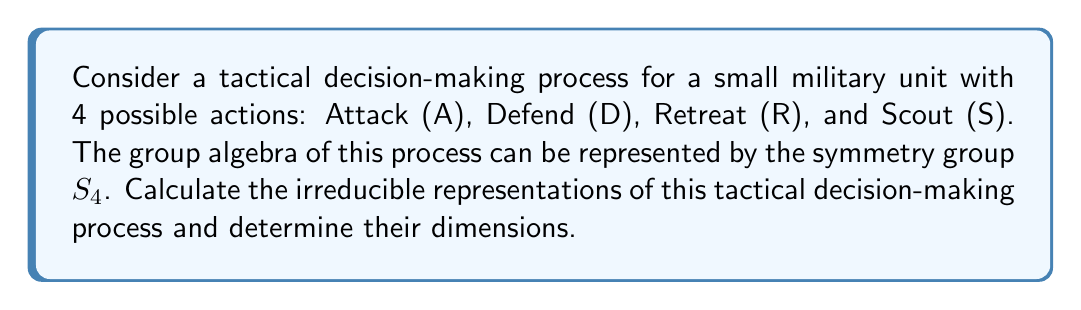Can you solve this math problem? To calculate the irreducible representations of the tactical decision-making process, we'll follow these steps:

1) First, recall that the number of irreducible representations of a group is equal to the number of conjugacy classes. For $S_4$, there are 5 conjugacy classes:
   - (1) Identity
   - (2) 2-cycles
   - (3) 3-cycles
   - (4) 4-cycles
   - (2,2) Double transpositions

2) The sum of the squares of the dimensions of the irreducible representations must equal the order of the group. For $S_4$, this means:

   $$d_1^2 + d_2^2 + d_3^2 + d_4^2 + d_5^2 = |S_4| = 24$$

3) We know that every group has a trivial representation of dimension 1, and $S_4$ has a sign representation of dimension 1.

4) $S_4$ acts on 4 points, giving a standard representation of dimension 3 (4 - 1 = 3).

5) Using the remaining two dimensions and the equation from step 2, we can deduce:

   $$1^2 + 1^2 + 3^2 + d_4^2 + d_5^2 = 24$$
   $$11 + d_4^2 + d_5^2 = 24$$
   $$d_4^2 + d_5^2 = 13$$

6) The only integer solution for this is $d_4 = 3$ and $d_5 = 2$.

Therefore, the irreducible representations of $S_4$, representing our tactical decision-making process, are of dimensions 1, 1, 3, 3, and 2.
Answer: The irreducible representations of $S_4$ have dimensions 1, 1, 2, 3, 3. 